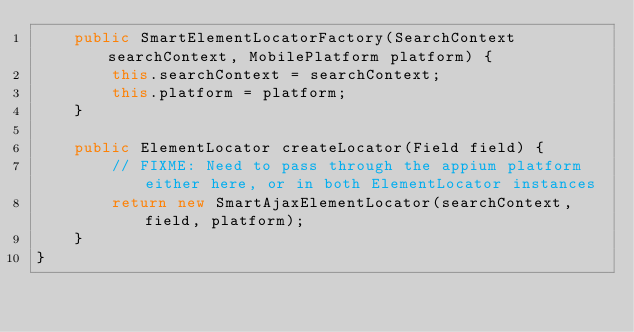Convert code to text. <code><loc_0><loc_0><loc_500><loc_500><_Java_>    public SmartElementLocatorFactory(SearchContext searchContext, MobilePlatform platform) {
        this.searchContext = searchContext;
        this.platform = platform;
    }

    public ElementLocator createLocator(Field field) {
        // FIXME: Need to pass through the appium platform either here, or in both ElementLocator instances
        return new SmartAjaxElementLocator(searchContext, field, platform);
    }
}</code> 